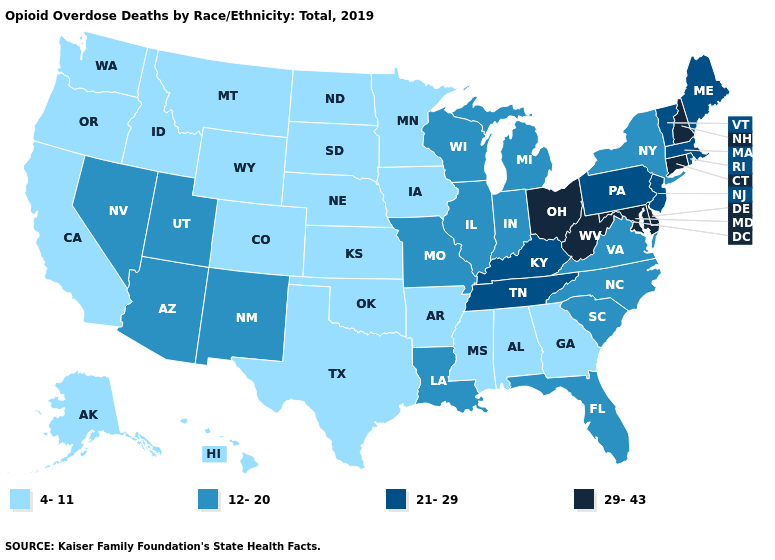What is the value of North Carolina?
Give a very brief answer. 12-20. Name the states that have a value in the range 12-20?
Short answer required. Arizona, Florida, Illinois, Indiana, Louisiana, Michigan, Missouri, Nevada, New Mexico, New York, North Carolina, South Carolina, Utah, Virginia, Wisconsin. What is the value of Vermont?
Answer briefly. 21-29. What is the value of Iowa?
Answer briefly. 4-11. What is the value of Oklahoma?
Give a very brief answer. 4-11. Which states have the lowest value in the Northeast?
Short answer required. New York. What is the value of South Dakota?
Short answer required. 4-11. Name the states that have a value in the range 21-29?
Concise answer only. Kentucky, Maine, Massachusetts, New Jersey, Pennsylvania, Rhode Island, Tennessee, Vermont. Which states have the lowest value in the USA?
Short answer required. Alabama, Alaska, Arkansas, California, Colorado, Georgia, Hawaii, Idaho, Iowa, Kansas, Minnesota, Mississippi, Montana, Nebraska, North Dakota, Oklahoma, Oregon, South Dakota, Texas, Washington, Wyoming. Among the states that border Indiana , does Kentucky have the lowest value?
Write a very short answer. No. What is the value of Nevada?
Answer briefly. 12-20. What is the value of Maine?
Short answer required. 21-29. Name the states that have a value in the range 12-20?
Write a very short answer. Arizona, Florida, Illinois, Indiana, Louisiana, Michigan, Missouri, Nevada, New Mexico, New York, North Carolina, South Carolina, Utah, Virginia, Wisconsin. Does Kansas have the highest value in the USA?
Give a very brief answer. No. What is the value of Washington?
Give a very brief answer. 4-11. 